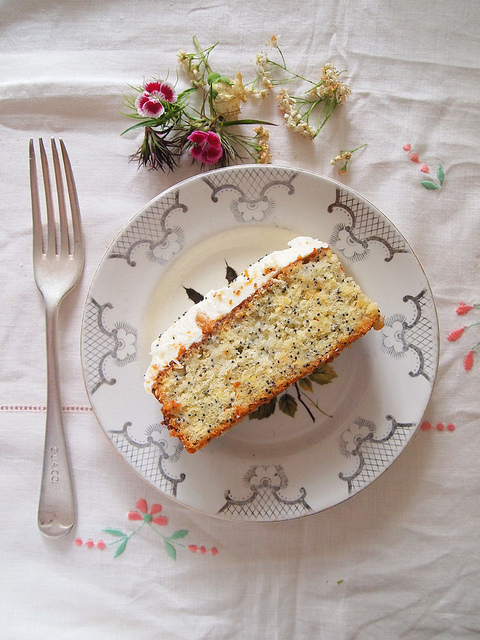Can you discuss the overall color palette featured in the image? The image boasts a harmonious color palette characterized by soft, pastel tones and subtle contrasts. The white tablecloth with delicate pink and grey embroidery complements the light beige and golden hues of the cake slice. The flower arrangement introduces pops of color with its vibrant pinks, gentle whites, and rich greens, adding a refreshing and lively touch to the overall aesthetic. 